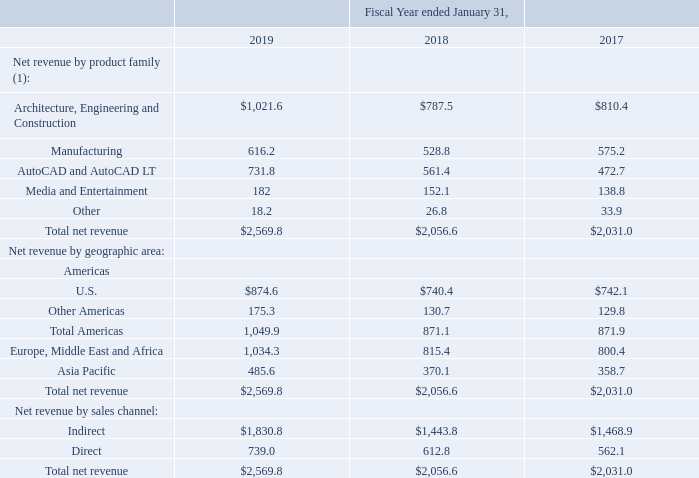Revenue Disaggregation
Autodesk recognizes revenue from the sale of (1) product subscriptions, cloud service offerings, and flexible enterprise business agreements ("EBAs"), (2) renewal fees for existing maintenance plan agreements that were initially purchased with a perpetual software license, and (3) consulting, training and other goods and services. The three categories are presented as line items on Autodesk's Consolidated Statements of Operations.
Information regarding the components of Autodesk's net revenue from contracts with customers by geographic location, product family, and sales channel is as follows:
(1) Due to changes in the go-to-market offerings of our AutoCAD product subscription, prior period balances have been adjusted to conform to current period presentation.
Payments for product subscriptions, industry collections, cloud subscriptions, and maintenance subscriptions are typically due up front with payment terms of 30 to 45 days. Payments on EBAs are typically due in annual installments over the contract term, with payment terms of 30 to 60 days. Autodesk does not have any material variable consideration, such as obligations for returns, refunds, or warranties or amounts payable to customers for which significant estimation or judgment is required as of the reporting date.
As of January 31, 2019, Autodesk had total billed and unbilled deferred revenue of $2.7 billion, which represents the total contract price allocated to undelivered performance obligations, which are generally recognized over the next three years. We expect to recognize $1.9 billion or 72% of this revenue during the next 12 months. We expect to recognize the remaining $0.8 billion or 28% of this revenue thereafter.
We expect that the amount of billed and unbilled deferred revenue will change from quarter to quarter for several reasons, including the specific timing, duration and size of customer subscription and support agreements, varying billing cycles of such agreements, the specific timing of customer renewals, and foreign currency fluctuations
What revenue does Autodesk recognize? Autodesk recognizes revenue from the sale of (1) product subscriptions, cloud service offerings, and flexible enterprise business agreements ("ebas"), (2) renewal fees for existing maintenance plan agreements that were initially purchased with a perpetual software license, and (3) consulting, training and other goods and services. What was the 2017 revenue from manufacturing?
Answer scale should be: million. 528.8. What are the payment terms for product subscriptions, industry collections, cloud subscriptions, and maintenance subscriptions? 30 to 45 days. What percentage of total net revenue in 2019 came from the US?
Answer scale should be: percent. 874.6/2,569.8
Answer: 34.03. What is the change in total net revenue from 2019 to 2018?
Answer scale should be: million. 2,569.8-2,056.6
Answer: 513.2. What is the total revenue from Manufacturing from 2018 to 2019? 
Answer scale should be: million. 528.8+616.2 
Answer: 1145. 